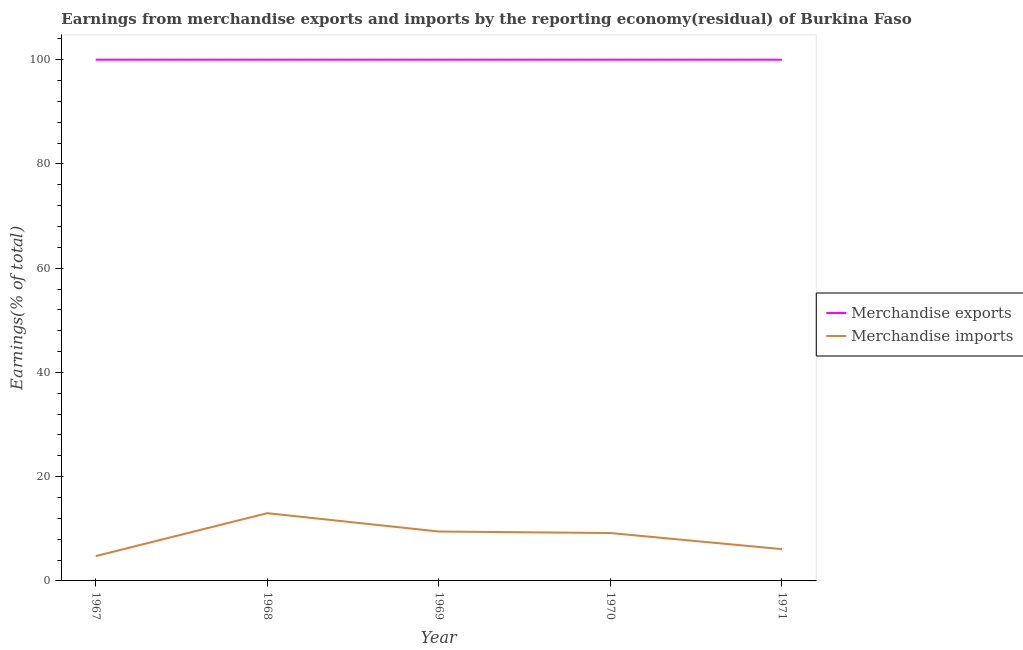How many different coloured lines are there?
Your answer should be compact. 2. What is the earnings from merchandise exports in 1967?
Your response must be concise. 100. Across all years, what is the maximum earnings from merchandise exports?
Provide a short and direct response. 100. Across all years, what is the minimum earnings from merchandise exports?
Your answer should be very brief. 100. In which year was the earnings from merchandise exports maximum?
Keep it short and to the point. 1967. In which year was the earnings from merchandise exports minimum?
Provide a short and direct response. 1967. What is the total earnings from merchandise exports in the graph?
Your response must be concise. 500. What is the difference between the earnings from merchandise exports in 1968 and that in 1969?
Keep it short and to the point. 0. What is the difference between the earnings from merchandise imports in 1971 and the earnings from merchandise exports in 1969?
Provide a succinct answer. -93.9. What is the average earnings from merchandise exports per year?
Your answer should be very brief. 100. In the year 1967, what is the difference between the earnings from merchandise imports and earnings from merchandise exports?
Provide a succinct answer. -95.24. In how many years, is the earnings from merchandise imports greater than 60 %?
Provide a succinct answer. 0. What is the ratio of the earnings from merchandise exports in 1968 to that in 1969?
Ensure brevity in your answer.  1. What is the difference between the highest and the second highest earnings from merchandise exports?
Your answer should be compact. 0. What is the difference between the highest and the lowest earnings from merchandise imports?
Ensure brevity in your answer.  8.24. In how many years, is the earnings from merchandise exports greater than the average earnings from merchandise exports taken over all years?
Offer a terse response. 0. Does the earnings from merchandise exports monotonically increase over the years?
Offer a terse response. No. Is the earnings from merchandise imports strictly less than the earnings from merchandise exports over the years?
Make the answer very short. Yes. How many years are there in the graph?
Offer a very short reply. 5. How are the legend labels stacked?
Make the answer very short. Vertical. What is the title of the graph?
Offer a very short reply. Earnings from merchandise exports and imports by the reporting economy(residual) of Burkina Faso. What is the label or title of the X-axis?
Your answer should be very brief. Year. What is the label or title of the Y-axis?
Your answer should be very brief. Earnings(% of total). What is the Earnings(% of total) in Merchandise exports in 1967?
Provide a succinct answer. 100. What is the Earnings(% of total) in Merchandise imports in 1967?
Make the answer very short. 4.76. What is the Earnings(% of total) in Merchandise exports in 1968?
Ensure brevity in your answer.  100. What is the Earnings(% of total) in Merchandise imports in 1968?
Your answer should be compact. 13. What is the Earnings(% of total) of Merchandise imports in 1969?
Ensure brevity in your answer.  9.48. What is the Earnings(% of total) in Merchandise imports in 1970?
Offer a very short reply. 9.19. What is the Earnings(% of total) in Merchandise imports in 1971?
Give a very brief answer. 6.1. Across all years, what is the maximum Earnings(% of total) in Merchandise imports?
Give a very brief answer. 13. Across all years, what is the minimum Earnings(% of total) of Merchandise imports?
Keep it short and to the point. 4.76. What is the total Earnings(% of total) of Merchandise imports in the graph?
Provide a short and direct response. 42.52. What is the difference between the Earnings(% of total) in Merchandise imports in 1967 and that in 1968?
Your response must be concise. -8.24. What is the difference between the Earnings(% of total) in Merchandise imports in 1967 and that in 1969?
Your response must be concise. -4.72. What is the difference between the Earnings(% of total) of Merchandise exports in 1967 and that in 1970?
Keep it short and to the point. 0. What is the difference between the Earnings(% of total) of Merchandise imports in 1967 and that in 1970?
Your answer should be very brief. -4.43. What is the difference between the Earnings(% of total) in Merchandise imports in 1967 and that in 1971?
Ensure brevity in your answer.  -1.33. What is the difference between the Earnings(% of total) in Merchandise exports in 1968 and that in 1969?
Offer a terse response. 0. What is the difference between the Earnings(% of total) of Merchandise imports in 1968 and that in 1969?
Offer a very short reply. 3.52. What is the difference between the Earnings(% of total) in Merchandise imports in 1968 and that in 1970?
Offer a very short reply. 3.81. What is the difference between the Earnings(% of total) of Merchandise imports in 1968 and that in 1971?
Provide a short and direct response. 6.9. What is the difference between the Earnings(% of total) in Merchandise exports in 1969 and that in 1970?
Your answer should be very brief. 0. What is the difference between the Earnings(% of total) in Merchandise imports in 1969 and that in 1970?
Provide a short and direct response. 0.29. What is the difference between the Earnings(% of total) in Merchandise imports in 1969 and that in 1971?
Ensure brevity in your answer.  3.38. What is the difference between the Earnings(% of total) of Merchandise imports in 1970 and that in 1971?
Offer a terse response. 3.09. What is the difference between the Earnings(% of total) in Merchandise exports in 1967 and the Earnings(% of total) in Merchandise imports in 1968?
Give a very brief answer. 87. What is the difference between the Earnings(% of total) in Merchandise exports in 1967 and the Earnings(% of total) in Merchandise imports in 1969?
Ensure brevity in your answer.  90.52. What is the difference between the Earnings(% of total) in Merchandise exports in 1967 and the Earnings(% of total) in Merchandise imports in 1970?
Provide a succinct answer. 90.81. What is the difference between the Earnings(% of total) in Merchandise exports in 1967 and the Earnings(% of total) in Merchandise imports in 1971?
Provide a short and direct response. 93.9. What is the difference between the Earnings(% of total) of Merchandise exports in 1968 and the Earnings(% of total) of Merchandise imports in 1969?
Provide a succinct answer. 90.52. What is the difference between the Earnings(% of total) of Merchandise exports in 1968 and the Earnings(% of total) of Merchandise imports in 1970?
Offer a very short reply. 90.81. What is the difference between the Earnings(% of total) in Merchandise exports in 1968 and the Earnings(% of total) in Merchandise imports in 1971?
Ensure brevity in your answer.  93.9. What is the difference between the Earnings(% of total) in Merchandise exports in 1969 and the Earnings(% of total) in Merchandise imports in 1970?
Provide a succinct answer. 90.81. What is the difference between the Earnings(% of total) of Merchandise exports in 1969 and the Earnings(% of total) of Merchandise imports in 1971?
Make the answer very short. 93.9. What is the difference between the Earnings(% of total) of Merchandise exports in 1970 and the Earnings(% of total) of Merchandise imports in 1971?
Your response must be concise. 93.9. What is the average Earnings(% of total) of Merchandise exports per year?
Keep it short and to the point. 100. What is the average Earnings(% of total) in Merchandise imports per year?
Ensure brevity in your answer.  8.5. In the year 1967, what is the difference between the Earnings(% of total) of Merchandise exports and Earnings(% of total) of Merchandise imports?
Keep it short and to the point. 95.24. In the year 1968, what is the difference between the Earnings(% of total) in Merchandise exports and Earnings(% of total) in Merchandise imports?
Your answer should be compact. 87. In the year 1969, what is the difference between the Earnings(% of total) in Merchandise exports and Earnings(% of total) in Merchandise imports?
Ensure brevity in your answer.  90.52. In the year 1970, what is the difference between the Earnings(% of total) of Merchandise exports and Earnings(% of total) of Merchandise imports?
Keep it short and to the point. 90.81. In the year 1971, what is the difference between the Earnings(% of total) of Merchandise exports and Earnings(% of total) of Merchandise imports?
Your answer should be very brief. 93.9. What is the ratio of the Earnings(% of total) of Merchandise exports in 1967 to that in 1968?
Make the answer very short. 1. What is the ratio of the Earnings(% of total) in Merchandise imports in 1967 to that in 1968?
Provide a short and direct response. 0.37. What is the ratio of the Earnings(% of total) in Merchandise imports in 1967 to that in 1969?
Give a very brief answer. 0.5. What is the ratio of the Earnings(% of total) of Merchandise imports in 1967 to that in 1970?
Offer a terse response. 0.52. What is the ratio of the Earnings(% of total) in Merchandise exports in 1967 to that in 1971?
Provide a succinct answer. 1. What is the ratio of the Earnings(% of total) in Merchandise imports in 1967 to that in 1971?
Make the answer very short. 0.78. What is the ratio of the Earnings(% of total) of Merchandise imports in 1968 to that in 1969?
Provide a succinct answer. 1.37. What is the ratio of the Earnings(% of total) in Merchandise exports in 1968 to that in 1970?
Your answer should be compact. 1. What is the ratio of the Earnings(% of total) in Merchandise imports in 1968 to that in 1970?
Provide a succinct answer. 1.41. What is the ratio of the Earnings(% of total) of Merchandise exports in 1968 to that in 1971?
Offer a terse response. 1. What is the ratio of the Earnings(% of total) in Merchandise imports in 1968 to that in 1971?
Your answer should be compact. 2.13. What is the ratio of the Earnings(% of total) in Merchandise exports in 1969 to that in 1970?
Keep it short and to the point. 1. What is the ratio of the Earnings(% of total) of Merchandise imports in 1969 to that in 1970?
Keep it short and to the point. 1.03. What is the ratio of the Earnings(% of total) of Merchandise imports in 1969 to that in 1971?
Your answer should be very brief. 1.55. What is the ratio of the Earnings(% of total) in Merchandise imports in 1970 to that in 1971?
Your response must be concise. 1.51. What is the difference between the highest and the second highest Earnings(% of total) in Merchandise exports?
Give a very brief answer. 0. What is the difference between the highest and the second highest Earnings(% of total) in Merchandise imports?
Provide a short and direct response. 3.52. What is the difference between the highest and the lowest Earnings(% of total) in Merchandise exports?
Ensure brevity in your answer.  0. What is the difference between the highest and the lowest Earnings(% of total) of Merchandise imports?
Your answer should be compact. 8.24. 